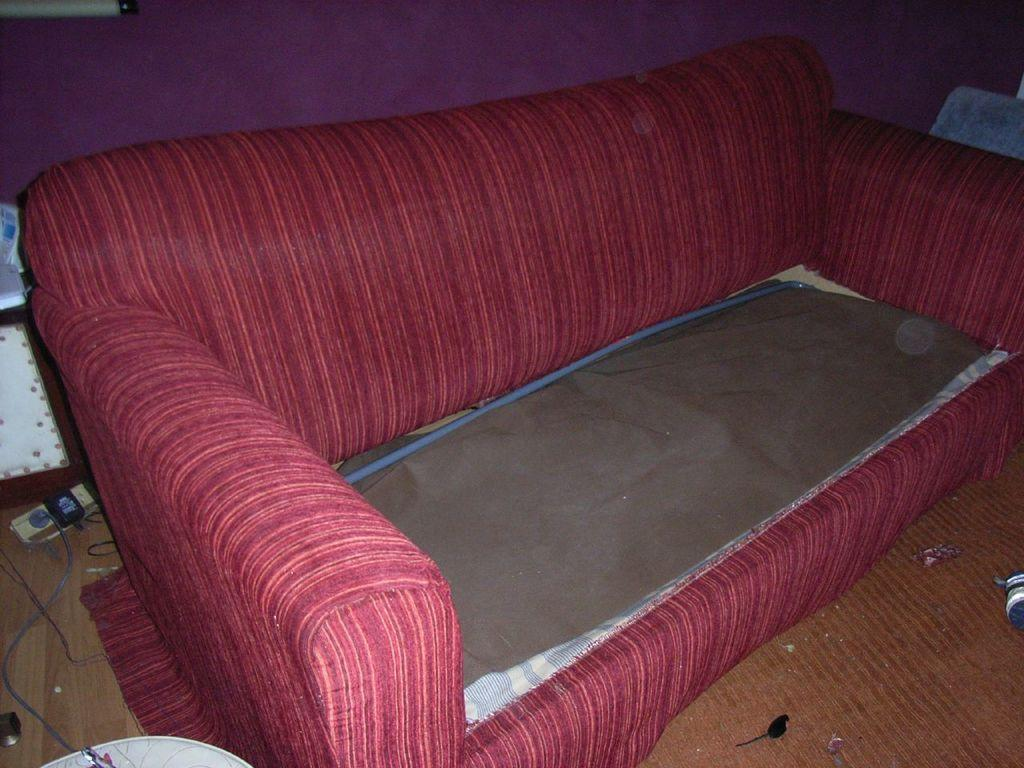What type of furniture is present in the image? There is a sofa in the image. What part of the room can be seen in the image? The floor is visible in the image. What architectural element is present in the image? There is a wall in the image. What type of popcorn is being served on the sofa in the image? There is no popcorn present in the image; it only features a sofa, floor, and wall. 